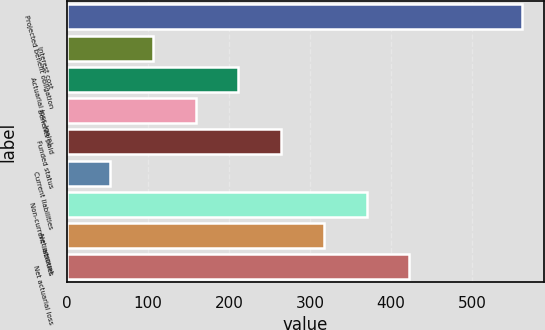Convert chart. <chart><loc_0><loc_0><loc_500><loc_500><bar_chart><fcel>Projected benefit obligation<fcel>Interest cost<fcel>Actuarial loss (gain)<fcel>Benefits paid<fcel>Funded status<fcel>Current liabilities<fcel>Non-current liabilities<fcel>Net amount<fcel>Net actuarial loss<nl><fcel>561.24<fcel>106.28<fcel>211.76<fcel>159.02<fcel>264.5<fcel>53.54<fcel>369.98<fcel>317.24<fcel>422.72<nl></chart> 